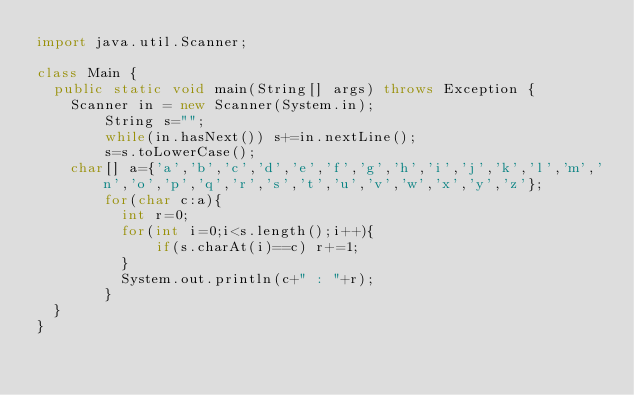<code> <loc_0><loc_0><loc_500><loc_500><_Java_>import java.util.Scanner;

class Main {
	public static void main(String[] args) throws Exception {
		Scanner in = new Scanner(System.in);
        String s="";
        while(in.hasNext()) s+=in.nextLine();
        s=s.toLowerCase();
		char[] a={'a','b','c','d','e','f','g','h','i','j','k','l','m','n','o','p','q','r','s','t','u','v','w','x','y','z'};
        for(char c:a){
        	int r=0;
        	for(int i=0;i<s.length();i++){
            	if(s.charAt(i)==c) r+=1; 
        	}
        	System.out.println(c+" : "+r);
        }
	}
}</code> 